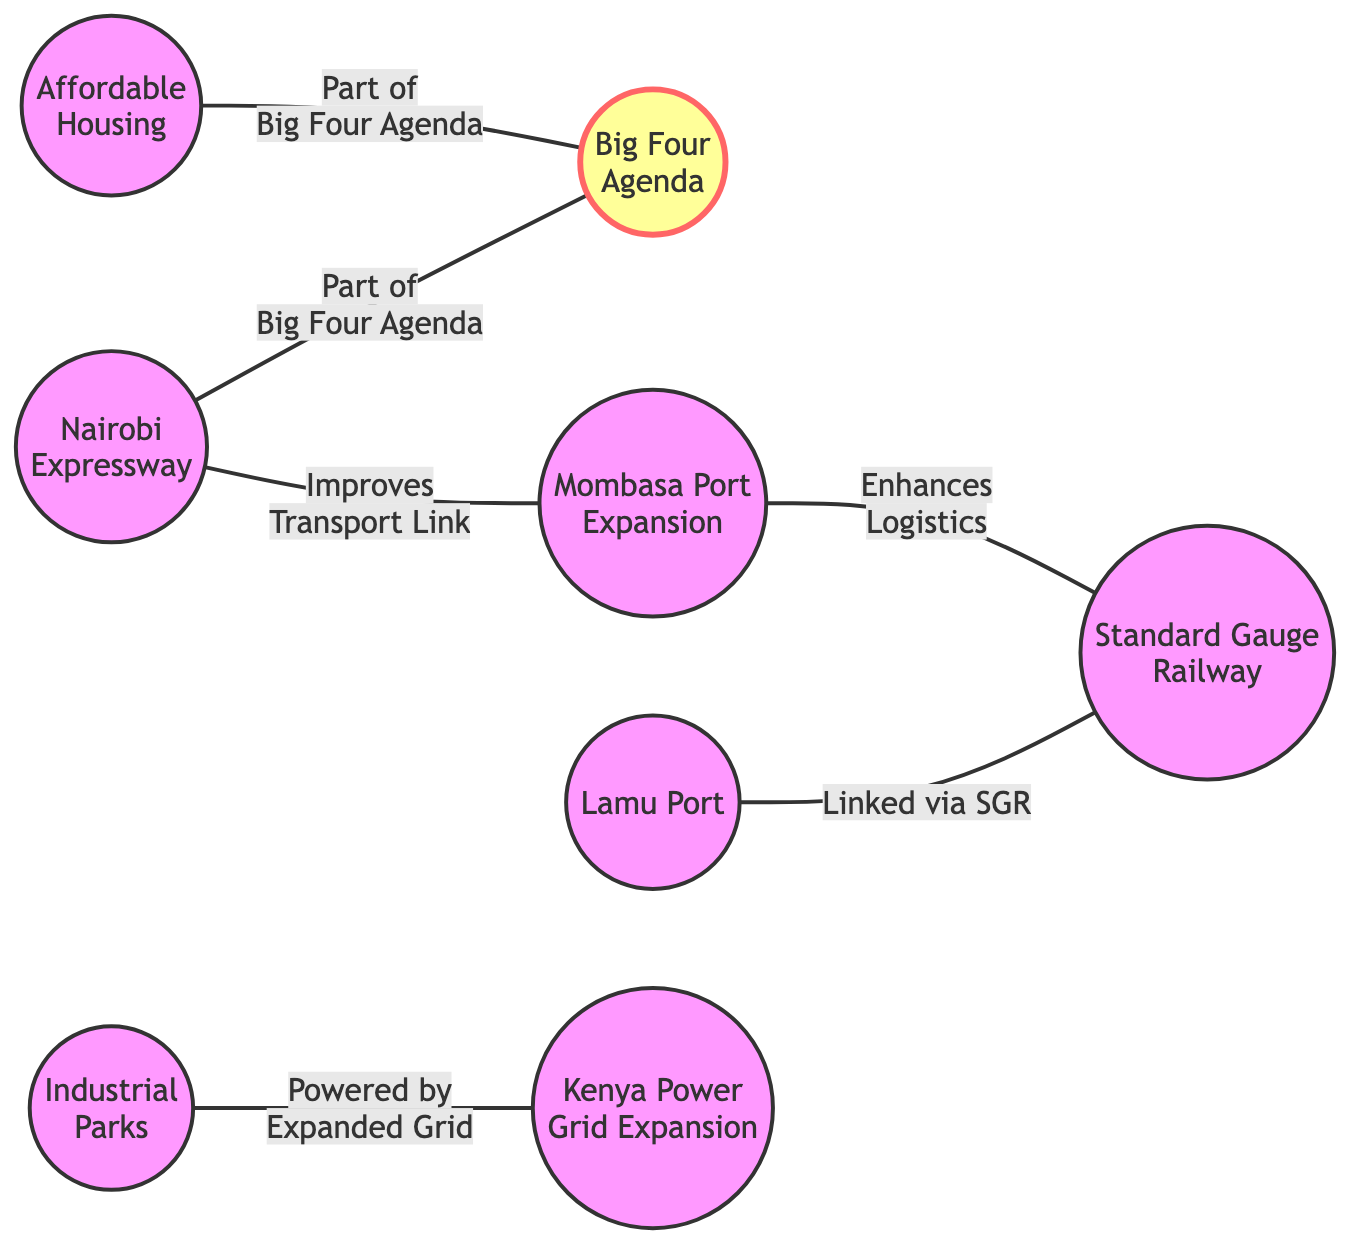What is the total number of nodes in the diagram? The diagram contains a list of distinct projects and initiatives that are the nodes, which are: Nairobi Expressway, Big Four Agenda, Lamu Port, Standard Gauge Railway, Affordable Housing, Mombasa Port Expansion, Industrial Parks, and Kenya Power Grid Expansion. Counting these, we find there are 8 nodes in total.
Answer: 8 What edge connects Nairobi Expressway and Big Four Agenda? The diagram shows an edge between Nairobi Expressway and Big Four Agenda, labeled as "Part of Big Four Agenda," indicating the relationship that the Nairobi Expressway is part of the larger initiative known as the Big Four Agenda.
Answer: Part of Big Four Agenda Which project is linked via the Standard Gauge Railway? According to the diagram, Lamu Port is connected to Standard Gauge Railway by the edge labeled "Linked via SGR," indicating that these two projects are directly associated through the railway.
Answer: Lamu Port How many edges are there in the diagram? The diagram lists all the connections between the projects, which are referred to as edges. Counting these connections: Nairobi Expressway to Big Four Agenda, Lamu Port to Standard Gauge Railway, Affordable Housing to Big Four Agenda, Mombasa Port Expansion to Standard Gauge Railway, Industrial Parks to Kenya Power Grid Expansion, and Nairobi Expressway to Mombasa Port Expansion, gives us a total of 6 edges.
Answer: 6 What enhances logistics according to the diagram? The connection labeled "Enhances Logistics" in the diagram indicates that Mombasa Port Expansion is linked to Standard Gauge Railway, suggesting that the Mombasa Port Expansion contributes positively to logistics through this connection.
Answer: Mombasa Port Expansion Which two projects are powered by the expanded grid? The diagram indicates a direct connection with the label "Powered by Expanded Grid" linking Industrial Parks to Kenya Power Grid Expansion, thus showing that these two projects are related through power infrastructure.
Answer: Industrial Parks, Kenya Power Grid Expansion Which project improves the transport link? The diagram shows that Nairobi Expressway is directly connected to Mombasa Port Expansion with an edge labeled "Improves Transport Link," indicating that these two projects are designed to enhance transportation between key areas.
Answer: Mombasa Port Expansion What is one component of the Big Four Agenda? The diagram features two nodes connected to Big Four Agenda, i.e., Nairobi Expressway and Affordable Housing. Both are essential components of the Big Four Agenda initiative under Ruto's administration.
Answer: Nairobi Expressway or Affordable Housing 